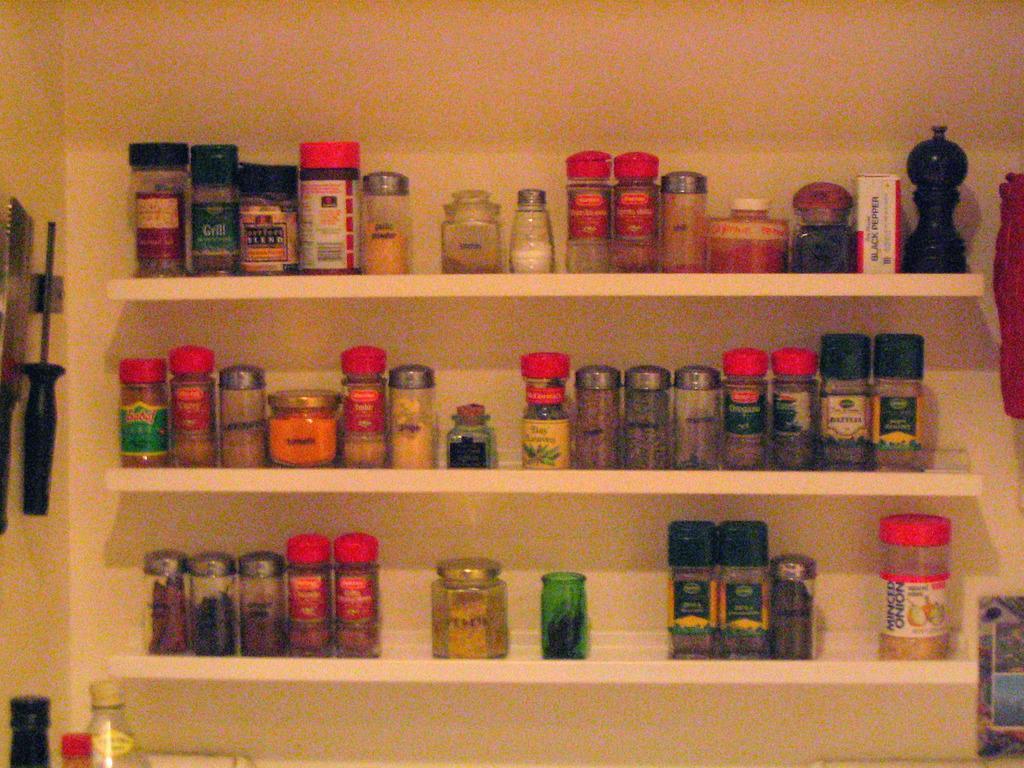Describe this image in one or two sentences. In this picture we can see containers with different ingredients in the shelves. Here at the bottom left corner of the picture we can see bottles. 